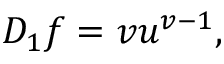Convert formula to latex. <formula><loc_0><loc_0><loc_500><loc_500>D _ { 1 } f = v u ^ { v - 1 } ,</formula> 